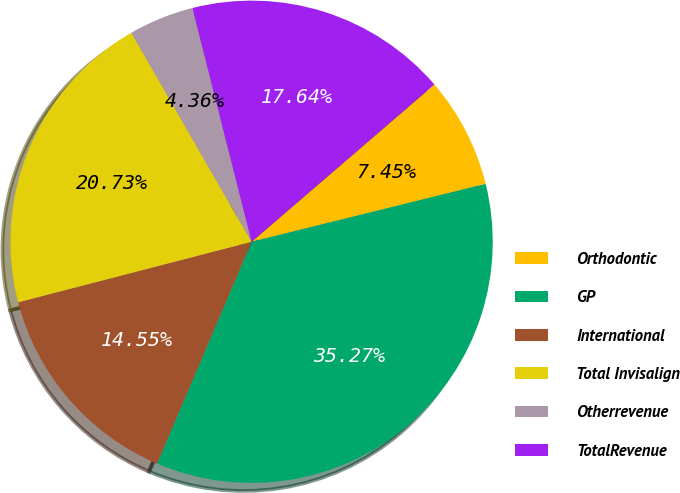Convert chart. <chart><loc_0><loc_0><loc_500><loc_500><pie_chart><fcel>Orthodontic<fcel>GP<fcel>International<fcel>Total Invisalign<fcel>Otherrevenue<fcel>TotalRevenue<nl><fcel>7.45%<fcel>35.27%<fcel>14.55%<fcel>20.73%<fcel>4.36%<fcel>17.64%<nl></chart> 